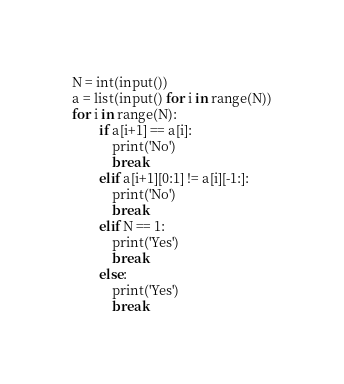Convert code to text. <code><loc_0><loc_0><loc_500><loc_500><_Python_>N = int(input())
a = list(input() for i in range(N))
for i in range(N):
		if a[i+1] == a[i]:
			print('No')
			break
		elif a[i+1][0:1] != a[i][-1:]:
			print('No')
			break
		elif N == 1:
			print('Yes')
			break
		else:
			print('Yes')
			break</code> 